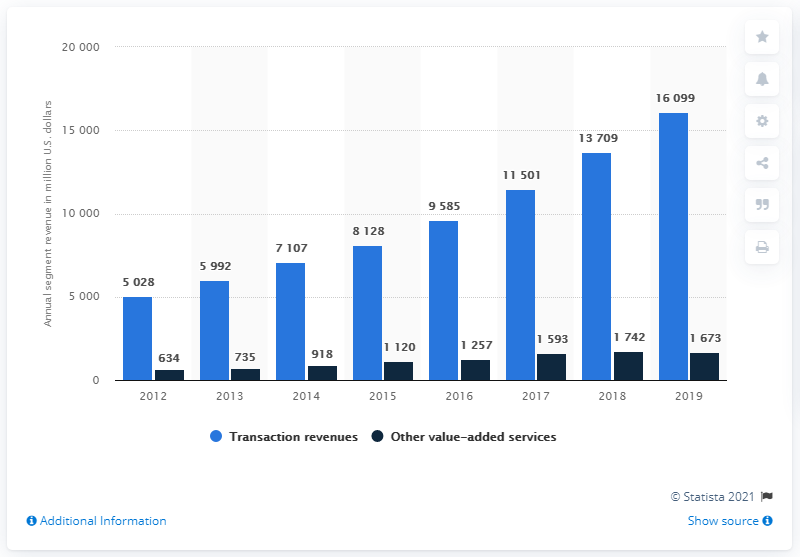How many dollars did other value-added services generate in revenue in 2019?
 1673 